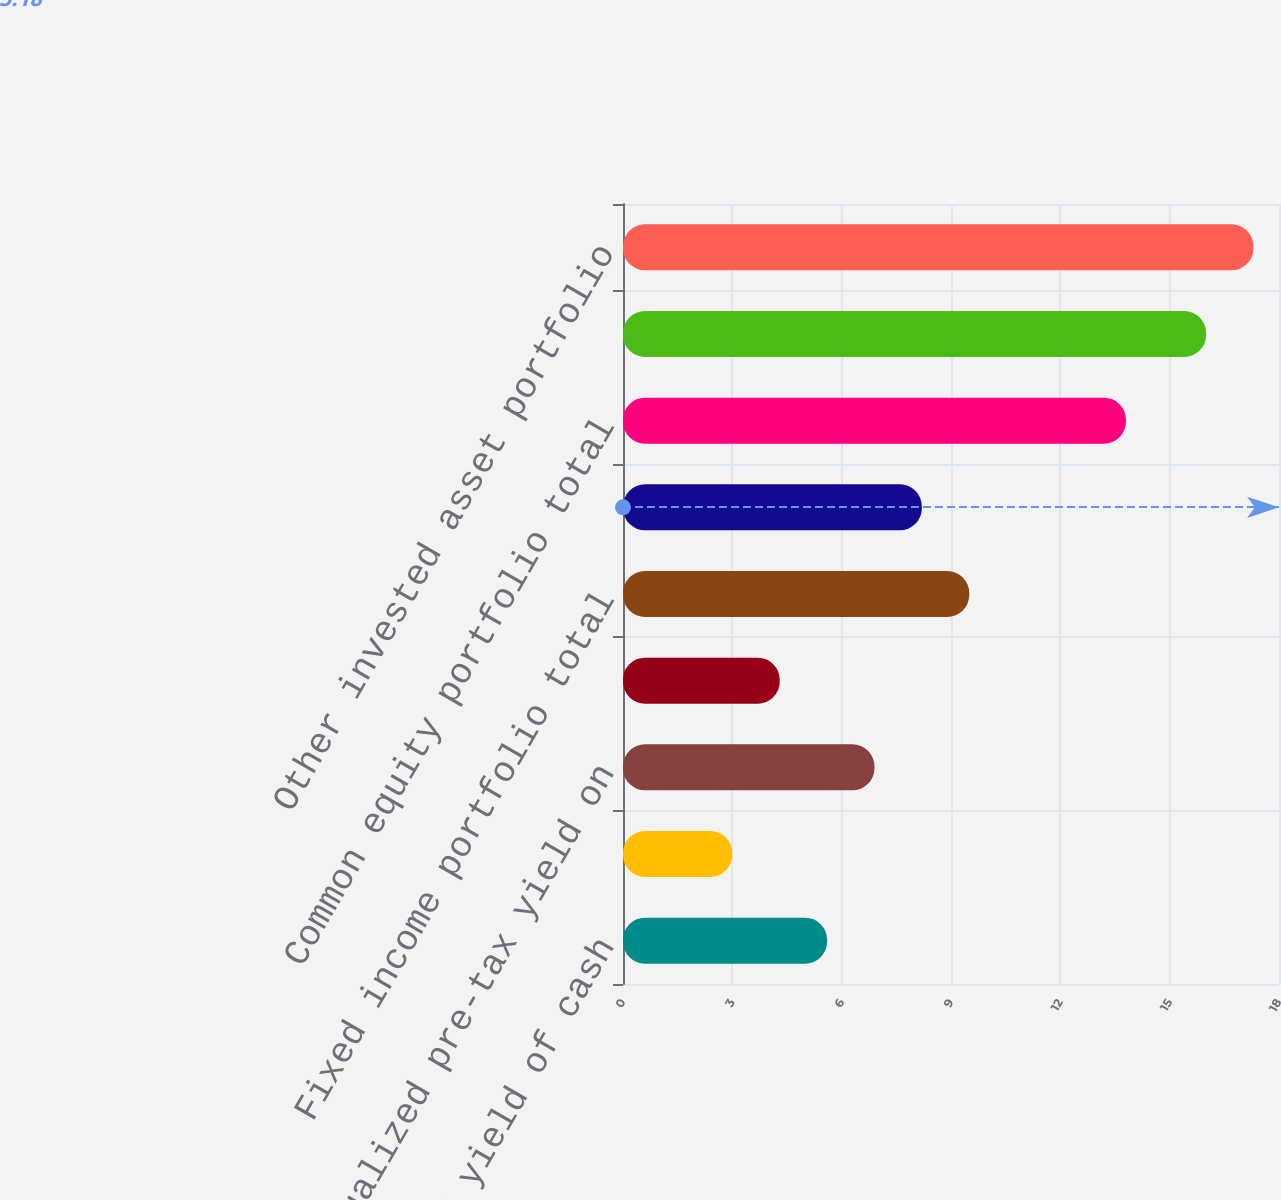Convert chart to OTSL. <chart><loc_0><loc_0><loc_500><loc_500><bar_chart><fcel>Imbedded pre-tax yield of cash<fcel>Imbedded after-tax yield of<fcel>Annualized pre-tax yield on<fcel>Annualized after-tax yield on<fcel>Fixed income portfolio total<fcel>Barclay's Capital - US<fcel>Common equity portfolio total<fcel>S&P 500 index<fcel>Other invested asset portfolio<nl><fcel>5.6<fcel>3<fcel>6.9<fcel>4.3<fcel>9.5<fcel>8.2<fcel>13.8<fcel>16<fcel>17.3<nl></chart> 